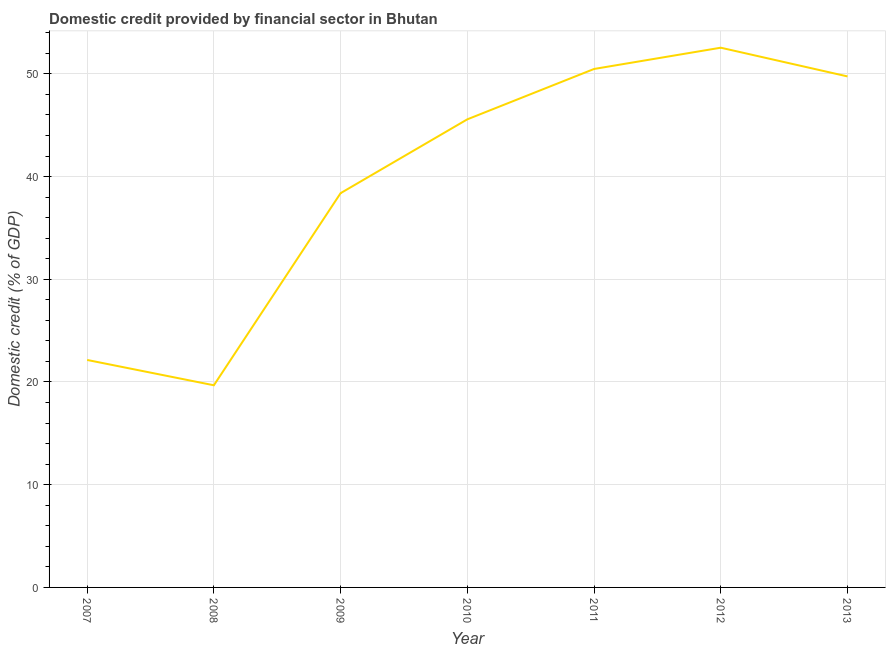What is the domestic credit provided by financial sector in 2007?
Keep it short and to the point. 22.15. Across all years, what is the maximum domestic credit provided by financial sector?
Offer a terse response. 52.55. Across all years, what is the minimum domestic credit provided by financial sector?
Your answer should be compact. 19.68. In which year was the domestic credit provided by financial sector minimum?
Provide a short and direct response. 2008. What is the sum of the domestic credit provided by financial sector?
Your answer should be very brief. 278.55. What is the difference between the domestic credit provided by financial sector in 2008 and 2012?
Make the answer very short. -32.86. What is the average domestic credit provided by financial sector per year?
Your response must be concise. 39.79. What is the median domestic credit provided by financial sector?
Offer a terse response. 45.57. In how many years, is the domestic credit provided by financial sector greater than 24 %?
Your response must be concise. 5. What is the ratio of the domestic credit provided by financial sector in 2008 to that in 2013?
Ensure brevity in your answer.  0.4. Is the domestic credit provided by financial sector in 2011 less than that in 2013?
Offer a very short reply. No. Is the difference between the domestic credit provided by financial sector in 2007 and 2011 greater than the difference between any two years?
Make the answer very short. No. What is the difference between the highest and the second highest domestic credit provided by financial sector?
Provide a short and direct response. 2.07. Is the sum of the domestic credit provided by financial sector in 2009 and 2011 greater than the maximum domestic credit provided by financial sector across all years?
Offer a very short reply. Yes. What is the difference between the highest and the lowest domestic credit provided by financial sector?
Provide a short and direct response. 32.86. In how many years, is the domestic credit provided by financial sector greater than the average domestic credit provided by financial sector taken over all years?
Provide a short and direct response. 4. How many lines are there?
Offer a very short reply. 1. What is the difference between two consecutive major ticks on the Y-axis?
Offer a very short reply. 10. What is the title of the graph?
Provide a short and direct response. Domestic credit provided by financial sector in Bhutan. What is the label or title of the Y-axis?
Provide a short and direct response. Domestic credit (% of GDP). What is the Domestic credit (% of GDP) of 2007?
Your response must be concise. 22.15. What is the Domestic credit (% of GDP) in 2008?
Provide a succinct answer. 19.68. What is the Domestic credit (% of GDP) in 2009?
Make the answer very short. 38.38. What is the Domestic credit (% of GDP) in 2010?
Your answer should be very brief. 45.57. What is the Domestic credit (% of GDP) in 2011?
Ensure brevity in your answer.  50.47. What is the Domestic credit (% of GDP) of 2012?
Your answer should be very brief. 52.55. What is the Domestic credit (% of GDP) in 2013?
Your answer should be very brief. 49.75. What is the difference between the Domestic credit (% of GDP) in 2007 and 2008?
Offer a very short reply. 2.47. What is the difference between the Domestic credit (% of GDP) in 2007 and 2009?
Provide a succinct answer. -16.24. What is the difference between the Domestic credit (% of GDP) in 2007 and 2010?
Make the answer very short. -23.43. What is the difference between the Domestic credit (% of GDP) in 2007 and 2011?
Offer a very short reply. -28.33. What is the difference between the Domestic credit (% of GDP) in 2007 and 2012?
Your response must be concise. -30.4. What is the difference between the Domestic credit (% of GDP) in 2007 and 2013?
Your answer should be compact. -27.6. What is the difference between the Domestic credit (% of GDP) in 2008 and 2009?
Provide a short and direct response. -18.7. What is the difference between the Domestic credit (% of GDP) in 2008 and 2010?
Your answer should be compact. -25.89. What is the difference between the Domestic credit (% of GDP) in 2008 and 2011?
Keep it short and to the point. -30.79. What is the difference between the Domestic credit (% of GDP) in 2008 and 2012?
Your response must be concise. -32.86. What is the difference between the Domestic credit (% of GDP) in 2008 and 2013?
Offer a very short reply. -30.07. What is the difference between the Domestic credit (% of GDP) in 2009 and 2010?
Offer a terse response. -7.19. What is the difference between the Domestic credit (% of GDP) in 2009 and 2011?
Ensure brevity in your answer.  -12.09. What is the difference between the Domestic credit (% of GDP) in 2009 and 2012?
Provide a short and direct response. -14.16. What is the difference between the Domestic credit (% of GDP) in 2009 and 2013?
Your response must be concise. -11.37. What is the difference between the Domestic credit (% of GDP) in 2010 and 2011?
Make the answer very short. -4.9. What is the difference between the Domestic credit (% of GDP) in 2010 and 2012?
Your response must be concise. -6.97. What is the difference between the Domestic credit (% of GDP) in 2010 and 2013?
Keep it short and to the point. -4.18. What is the difference between the Domestic credit (% of GDP) in 2011 and 2012?
Offer a very short reply. -2.07. What is the difference between the Domestic credit (% of GDP) in 2011 and 2013?
Keep it short and to the point. 0.72. What is the difference between the Domestic credit (% of GDP) in 2012 and 2013?
Keep it short and to the point. 2.8. What is the ratio of the Domestic credit (% of GDP) in 2007 to that in 2009?
Keep it short and to the point. 0.58. What is the ratio of the Domestic credit (% of GDP) in 2007 to that in 2010?
Your answer should be very brief. 0.49. What is the ratio of the Domestic credit (% of GDP) in 2007 to that in 2011?
Make the answer very short. 0.44. What is the ratio of the Domestic credit (% of GDP) in 2007 to that in 2012?
Keep it short and to the point. 0.42. What is the ratio of the Domestic credit (% of GDP) in 2007 to that in 2013?
Make the answer very short. 0.45. What is the ratio of the Domestic credit (% of GDP) in 2008 to that in 2009?
Make the answer very short. 0.51. What is the ratio of the Domestic credit (% of GDP) in 2008 to that in 2010?
Your response must be concise. 0.43. What is the ratio of the Domestic credit (% of GDP) in 2008 to that in 2011?
Your answer should be compact. 0.39. What is the ratio of the Domestic credit (% of GDP) in 2008 to that in 2013?
Provide a succinct answer. 0.4. What is the ratio of the Domestic credit (% of GDP) in 2009 to that in 2010?
Offer a terse response. 0.84. What is the ratio of the Domestic credit (% of GDP) in 2009 to that in 2011?
Provide a succinct answer. 0.76. What is the ratio of the Domestic credit (% of GDP) in 2009 to that in 2012?
Give a very brief answer. 0.73. What is the ratio of the Domestic credit (% of GDP) in 2009 to that in 2013?
Ensure brevity in your answer.  0.77. What is the ratio of the Domestic credit (% of GDP) in 2010 to that in 2011?
Keep it short and to the point. 0.9. What is the ratio of the Domestic credit (% of GDP) in 2010 to that in 2012?
Your answer should be very brief. 0.87. What is the ratio of the Domestic credit (% of GDP) in 2010 to that in 2013?
Keep it short and to the point. 0.92. What is the ratio of the Domestic credit (% of GDP) in 2011 to that in 2013?
Offer a very short reply. 1.01. What is the ratio of the Domestic credit (% of GDP) in 2012 to that in 2013?
Ensure brevity in your answer.  1.06. 